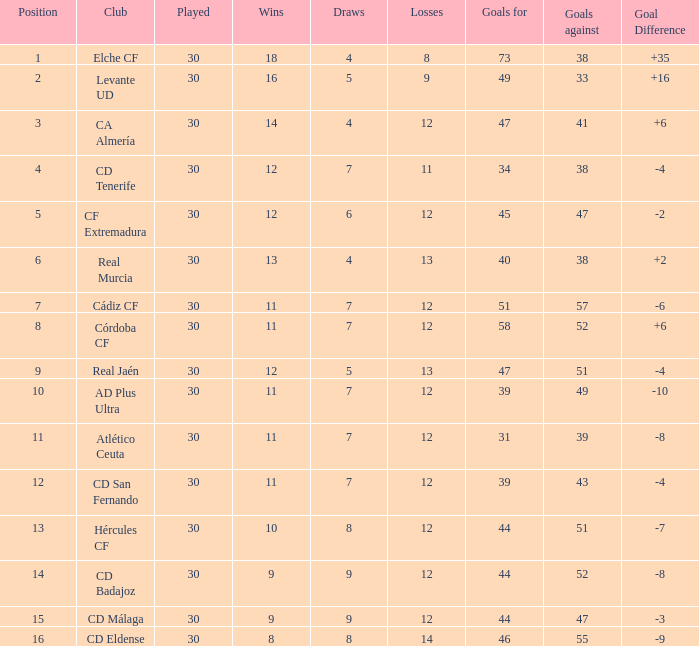What is the highest amount of goals with more than 51 goals against and less than 30 played? None. 